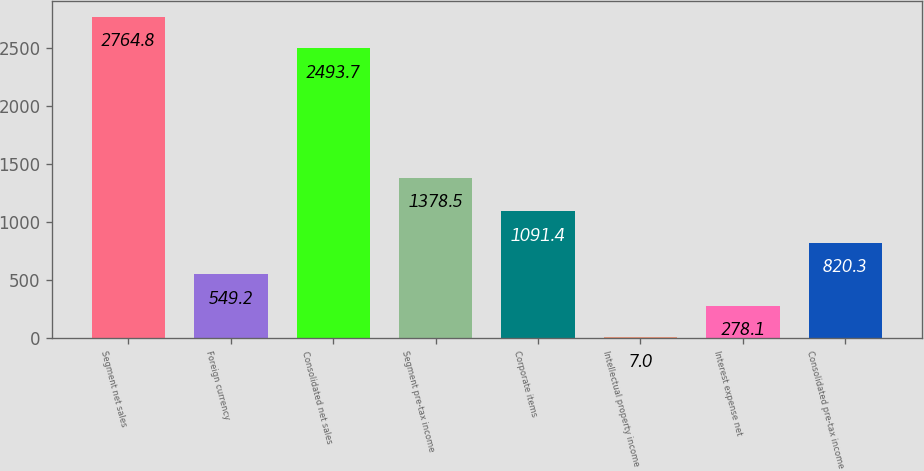Convert chart to OTSL. <chart><loc_0><loc_0><loc_500><loc_500><bar_chart><fcel>Segment net sales<fcel>Foreign currency<fcel>Consolidated net sales<fcel>Segment pre-tax income<fcel>Corporate items<fcel>Intellectual property income<fcel>Interest expense net<fcel>Consolidated pre-tax income<nl><fcel>2764.8<fcel>549.2<fcel>2493.7<fcel>1378.5<fcel>1091.4<fcel>7<fcel>278.1<fcel>820.3<nl></chart> 